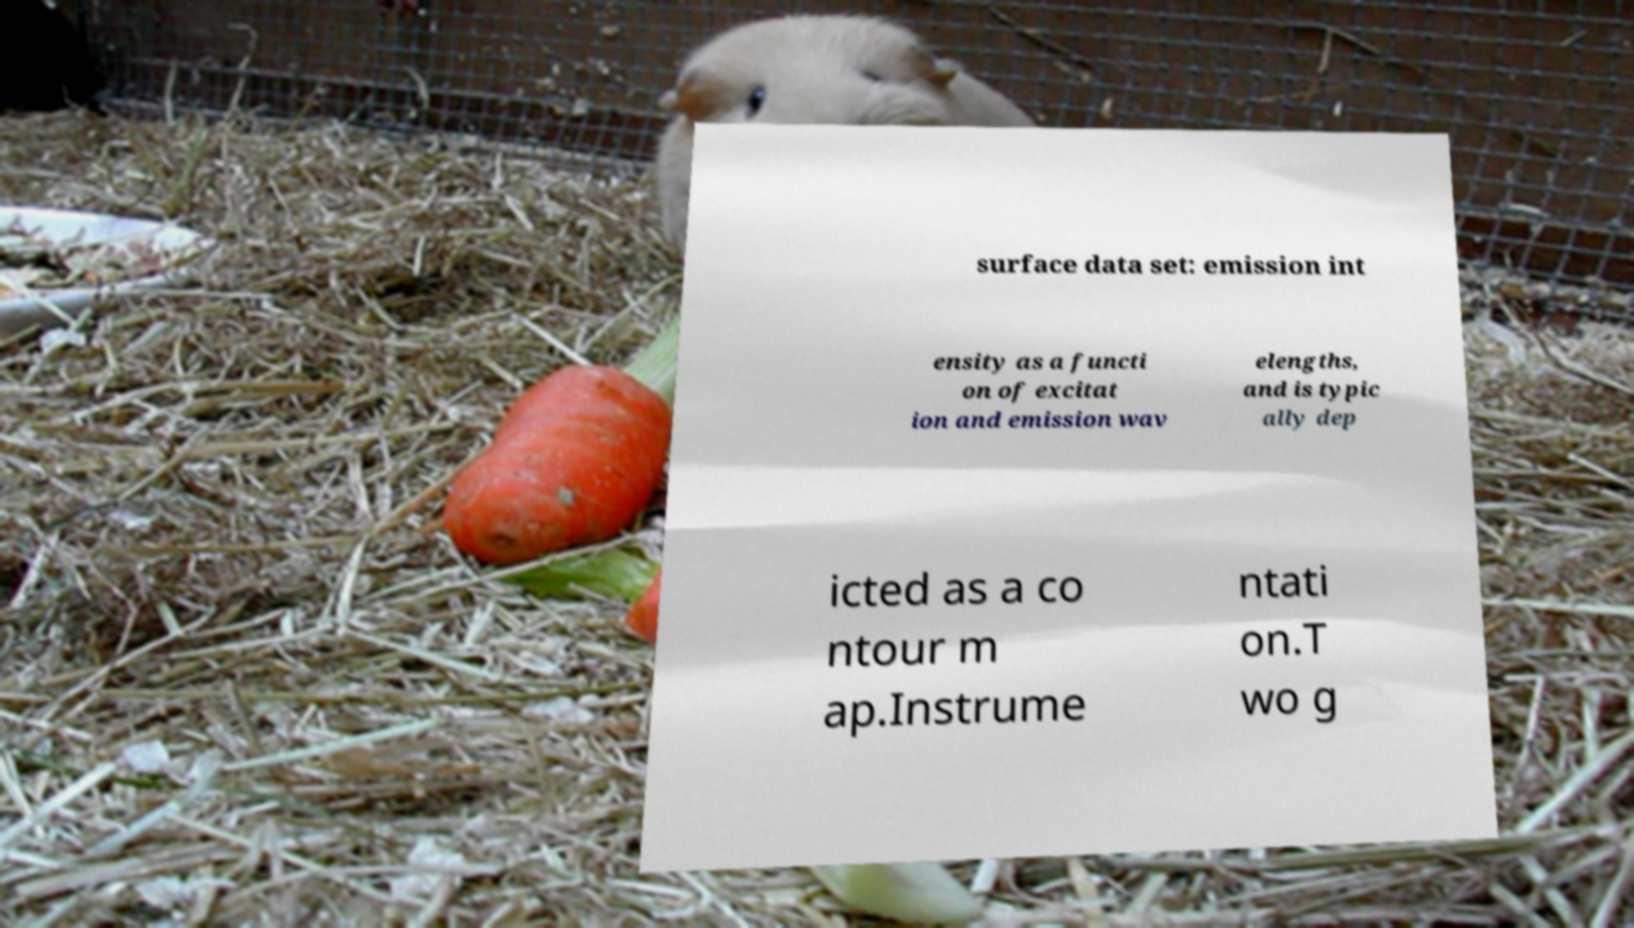Can you read and provide the text displayed in the image?This photo seems to have some interesting text. Can you extract and type it out for me? surface data set: emission int ensity as a functi on of excitat ion and emission wav elengths, and is typic ally dep icted as a co ntour m ap.Instrume ntati on.T wo g 